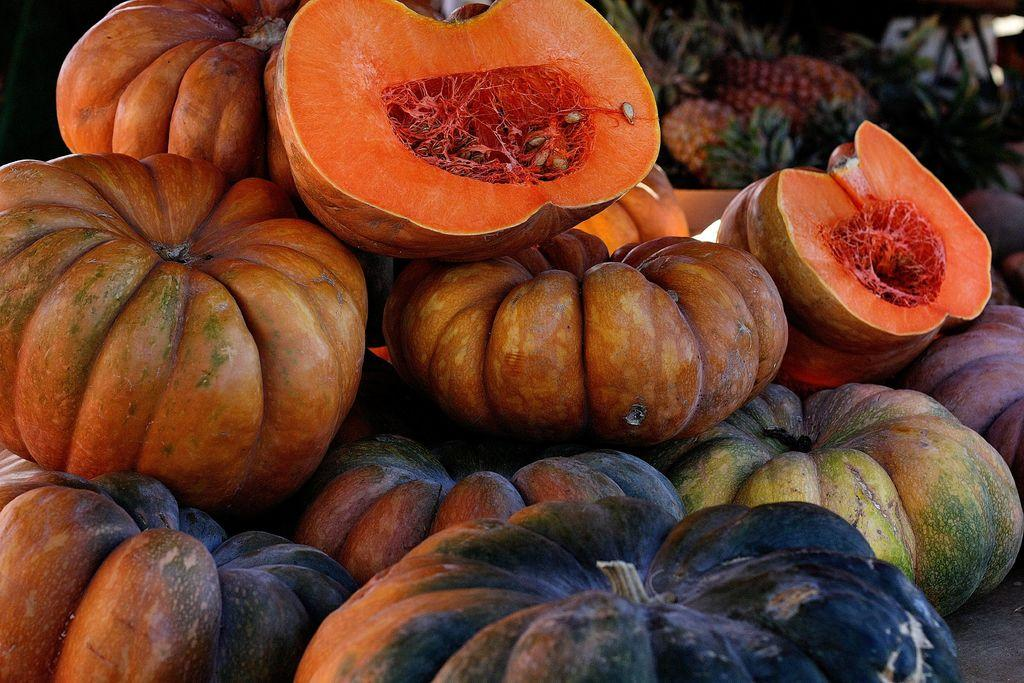What type of fruits are present in the image? There are pumpkins and pineapples in the image. Can you describe the location of the pineapples in the image? The pineapples are in the background of the image. What type of basin is used to compare the size of the pumpkins in the image? There is no basin or comparison of pumpkin sizes present in the image. 